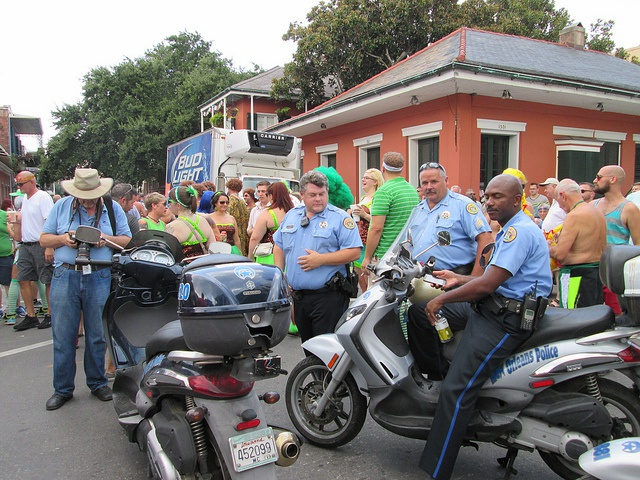Describe the objects in this image and their specific colors. I can see motorcycle in white, black, gray, darkgray, and lightgray tones, motorcycle in white, black, gray, darkgray, and lightgray tones, people in white, black, lightblue, and brown tones, people in white, gray, black, blue, and navy tones, and people in white, brown, lightgray, tan, and darkgray tones in this image. 